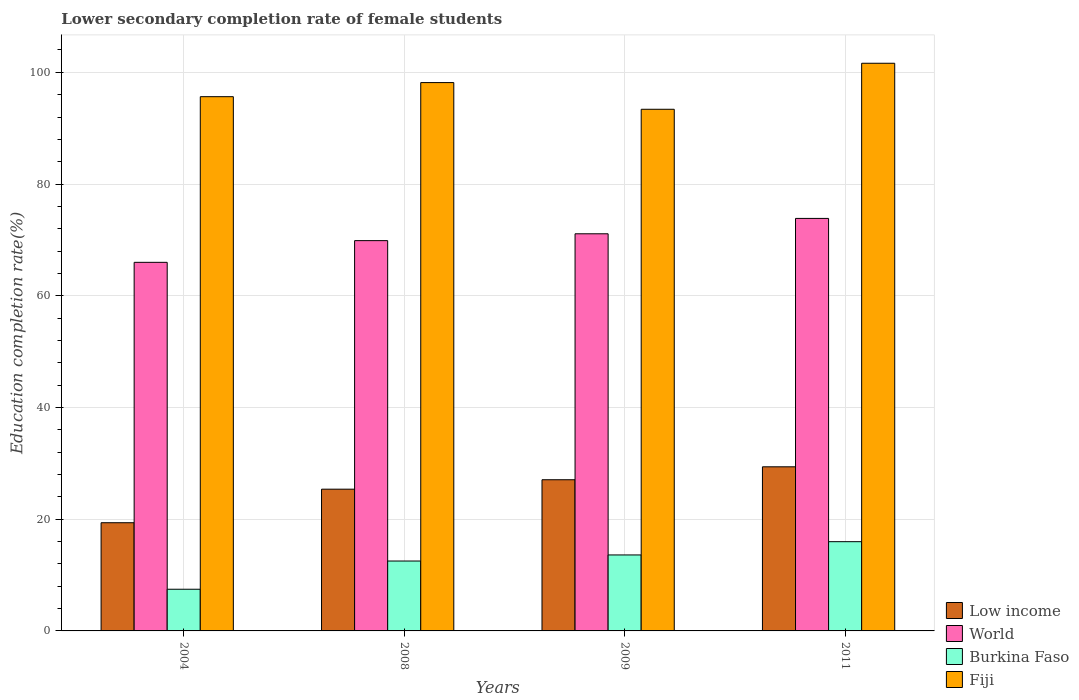How many different coloured bars are there?
Your answer should be very brief. 4. Are the number of bars on each tick of the X-axis equal?
Ensure brevity in your answer.  Yes. How many bars are there on the 3rd tick from the left?
Your response must be concise. 4. What is the lower secondary completion rate of female students in Fiji in 2004?
Give a very brief answer. 95.64. Across all years, what is the maximum lower secondary completion rate of female students in Fiji?
Provide a succinct answer. 101.62. Across all years, what is the minimum lower secondary completion rate of female students in Low income?
Provide a short and direct response. 19.37. In which year was the lower secondary completion rate of female students in World minimum?
Keep it short and to the point. 2004. What is the total lower secondary completion rate of female students in Burkina Faso in the graph?
Give a very brief answer. 49.55. What is the difference between the lower secondary completion rate of female students in Low income in 2008 and that in 2009?
Your response must be concise. -1.69. What is the difference between the lower secondary completion rate of female students in Fiji in 2011 and the lower secondary completion rate of female students in Burkina Faso in 2009?
Provide a short and direct response. 88.02. What is the average lower secondary completion rate of female students in World per year?
Keep it short and to the point. 70.2. In the year 2009, what is the difference between the lower secondary completion rate of female students in Low income and lower secondary completion rate of female students in World?
Offer a terse response. -44.03. In how many years, is the lower secondary completion rate of female students in Low income greater than 72 %?
Your answer should be compact. 0. What is the ratio of the lower secondary completion rate of female students in Fiji in 2008 to that in 2009?
Ensure brevity in your answer.  1.05. Is the difference between the lower secondary completion rate of female students in Low income in 2008 and 2011 greater than the difference between the lower secondary completion rate of female students in World in 2008 and 2011?
Offer a very short reply. No. What is the difference between the highest and the second highest lower secondary completion rate of female students in Fiji?
Offer a terse response. 3.46. What is the difference between the highest and the lowest lower secondary completion rate of female students in World?
Give a very brief answer. 7.86. In how many years, is the lower secondary completion rate of female students in Low income greater than the average lower secondary completion rate of female students in Low income taken over all years?
Give a very brief answer. 3. Is the sum of the lower secondary completion rate of female students in World in 2004 and 2011 greater than the maximum lower secondary completion rate of female students in Fiji across all years?
Ensure brevity in your answer.  Yes. What does the 1st bar from the left in 2009 represents?
Offer a very short reply. Low income. What does the 2nd bar from the right in 2004 represents?
Your answer should be compact. Burkina Faso. Are all the bars in the graph horizontal?
Offer a very short reply. No. How many years are there in the graph?
Ensure brevity in your answer.  4. What is the difference between two consecutive major ticks on the Y-axis?
Your answer should be compact. 20. Does the graph contain grids?
Make the answer very short. Yes. What is the title of the graph?
Provide a short and direct response. Lower secondary completion rate of female students. What is the label or title of the X-axis?
Your response must be concise. Years. What is the label or title of the Y-axis?
Ensure brevity in your answer.  Education completion rate(%). What is the Education completion rate(%) in Low income in 2004?
Ensure brevity in your answer.  19.37. What is the Education completion rate(%) in World in 2004?
Offer a very short reply. 65.98. What is the Education completion rate(%) in Burkina Faso in 2004?
Provide a short and direct response. 7.46. What is the Education completion rate(%) of Fiji in 2004?
Provide a short and direct response. 95.64. What is the Education completion rate(%) of Low income in 2008?
Your response must be concise. 25.38. What is the Education completion rate(%) in World in 2008?
Give a very brief answer. 69.87. What is the Education completion rate(%) of Burkina Faso in 2008?
Offer a very short reply. 12.51. What is the Education completion rate(%) in Fiji in 2008?
Your answer should be very brief. 98.16. What is the Education completion rate(%) in Low income in 2009?
Your answer should be compact. 27.06. What is the Education completion rate(%) in World in 2009?
Your answer should be compact. 71.09. What is the Education completion rate(%) of Burkina Faso in 2009?
Your response must be concise. 13.6. What is the Education completion rate(%) of Fiji in 2009?
Keep it short and to the point. 93.39. What is the Education completion rate(%) in Low income in 2011?
Your response must be concise. 29.38. What is the Education completion rate(%) in World in 2011?
Your answer should be very brief. 73.85. What is the Education completion rate(%) in Burkina Faso in 2011?
Provide a succinct answer. 15.98. What is the Education completion rate(%) of Fiji in 2011?
Ensure brevity in your answer.  101.62. Across all years, what is the maximum Education completion rate(%) of Low income?
Give a very brief answer. 29.38. Across all years, what is the maximum Education completion rate(%) of World?
Your response must be concise. 73.85. Across all years, what is the maximum Education completion rate(%) in Burkina Faso?
Provide a short and direct response. 15.98. Across all years, what is the maximum Education completion rate(%) of Fiji?
Offer a very short reply. 101.62. Across all years, what is the minimum Education completion rate(%) of Low income?
Your response must be concise. 19.37. Across all years, what is the minimum Education completion rate(%) of World?
Provide a short and direct response. 65.98. Across all years, what is the minimum Education completion rate(%) in Burkina Faso?
Provide a succinct answer. 7.46. Across all years, what is the minimum Education completion rate(%) in Fiji?
Offer a terse response. 93.39. What is the total Education completion rate(%) in Low income in the graph?
Your answer should be compact. 101.19. What is the total Education completion rate(%) of World in the graph?
Your response must be concise. 280.8. What is the total Education completion rate(%) in Burkina Faso in the graph?
Your response must be concise. 49.55. What is the total Education completion rate(%) in Fiji in the graph?
Offer a very short reply. 388.81. What is the difference between the Education completion rate(%) of Low income in 2004 and that in 2008?
Your answer should be very brief. -6.01. What is the difference between the Education completion rate(%) of World in 2004 and that in 2008?
Make the answer very short. -3.89. What is the difference between the Education completion rate(%) in Burkina Faso in 2004 and that in 2008?
Offer a terse response. -5.05. What is the difference between the Education completion rate(%) in Fiji in 2004 and that in 2008?
Provide a succinct answer. -2.52. What is the difference between the Education completion rate(%) in Low income in 2004 and that in 2009?
Offer a very short reply. -7.7. What is the difference between the Education completion rate(%) of World in 2004 and that in 2009?
Your response must be concise. -5.11. What is the difference between the Education completion rate(%) of Burkina Faso in 2004 and that in 2009?
Give a very brief answer. -6.14. What is the difference between the Education completion rate(%) of Fiji in 2004 and that in 2009?
Provide a short and direct response. 2.25. What is the difference between the Education completion rate(%) in Low income in 2004 and that in 2011?
Make the answer very short. -10.01. What is the difference between the Education completion rate(%) of World in 2004 and that in 2011?
Keep it short and to the point. -7.86. What is the difference between the Education completion rate(%) of Burkina Faso in 2004 and that in 2011?
Provide a succinct answer. -8.52. What is the difference between the Education completion rate(%) of Fiji in 2004 and that in 2011?
Offer a terse response. -5.98. What is the difference between the Education completion rate(%) in Low income in 2008 and that in 2009?
Your answer should be very brief. -1.69. What is the difference between the Education completion rate(%) of World in 2008 and that in 2009?
Provide a succinct answer. -1.22. What is the difference between the Education completion rate(%) of Burkina Faso in 2008 and that in 2009?
Give a very brief answer. -1.09. What is the difference between the Education completion rate(%) in Fiji in 2008 and that in 2009?
Ensure brevity in your answer.  4.78. What is the difference between the Education completion rate(%) of Low income in 2008 and that in 2011?
Your answer should be very brief. -4. What is the difference between the Education completion rate(%) in World in 2008 and that in 2011?
Give a very brief answer. -3.98. What is the difference between the Education completion rate(%) in Burkina Faso in 2008 and that in 2011?
Make the answer very short. -3.46. What is the difference between the Education completion rate(%) of Fiji in 2008 and that in 2011?
Provide a short and direct response. -3.46. What is the difference between the Education completion rate(%) of Low income in 2009 and that in 2011?
Your response must be concise. -2.31. What is the difference between the Education completion rate(%) of World in 2009 and that in 2011?
Ensure brevity in your answer.  -2.75. What is the difference between the Education completion rate(%) in Burkina Faso in 2009 and that in 2011?
Offer a terse response. -2.38. What is the difference between the Education completion rate(%) in Fiji in 2009 and that in 2011?
Give a very brief answer. -8.24. What is the difference between the Education completion rate(%) of Low income in 2004 and the Education completion rate(%) of World in 2008?
Your response must be concise. -50.5. What is the difference between the Education completion rate(%) of Low income in 2004 and the Education completion rate(%) of Burkina Faso in 2008?
Offer a terse response. 6.85. What is the difference between the Education completion rate(%) of Low income in 2004 and the Education completion rate(%) of Fiji in 2008?
Your response must be concise. -78.79. What is the difference between the Education completion rate(%) in World in 2004 and the Education completion rate(%) in Burkina Faso in 2008?
Keep it short and to the point. 53.47. What is the difference between the Education completion rate(%) in World in 2004 and the Education completion rate(%) in Fiji in 2008?
Provide a succinct answer. -32.18. What is the difference between the Education completion rate(%) in Burkina Faso in 2004 and the Education completion rate(%) in Fiji in 2008?
Keep it short and to the point. -90.7. What is the difference between the Education completion rate(%) in Low income in 2004 and the Education completion rate(%) in World in 2009?
Ensure brevity in your answer.  -51.73. What is the difference between the Education completion rate(%) of Low income in 2004 and the Education completion rate(%) of Burkina Faso in 2009?
Keep it short and to the point. 5.77. What is the difference between the Education completion rate(%) in Low income in 2004 and the Education completion rate(%) in Fiji in 2009?
Offer a terse response. -74.02. What is the difference between the Education completion rate(%) in World in 2004 and the Education completion rate(%) in Burkina Faso in 2009?
Your response must be concise. 52.38. What is the difference between the Education completion rate(%) in World in 2004 and the Education completion rate(%) in Fiji in 2009?
Give a very brief answer. -27.4. What is the difference between the Education completion rate(%) of Burkina Faso in 2004 and the Education completion rate(%) of Fiji in 2009?
Your answer should be compact. -85.93. What is the difference between the Education completion rate(%) of Low income in 2004 and the Education completion rate(%) of World in 2011?
Your response must be concise. -54.48. What is the difference between the Education completion rate(%) in Low income in 2004 and the Education completion rate(%) in Burkina Faso in 2011?
Give a very brief answer. 3.39. What is the difference between the Education completion rate(%) in Low income in 2004 and the Education completion rate(%) in Fiji in 2011?
Keep it short and to the point. -82.26. What is the difference between the Education completion rate(%) of World in 2004 and the Education completion rate(%) of Burkina Faso in 2011?
Your answer should be very brief. 50.01. What is the difference between the Education completion rate(%) in World in 2004 and the Education completion rate(%) in Fiji in 2011?
Offer a very short reply. -35.64. What is the difference between the Education completion rate(%) of Burkina Faso in 2004 and the Education completion rate(%) of Fiji in 2011?
Provide a succinct answer. -94.16. What is the difference between the Education completion rate(%) in Low income in 2008 and the Education completion rate(%) in World in 2009?
Make the answer very short. -45.72. What is the difference between the Education completion rate(%) in Low income in 2008 and the Education completion rate(%) in Burkina Faso in 2009?
Ensure brevity in your answer.  11.78. What is the difference between the Education completion rate(%) of Low income in 2008 and the Education completion rate(%) of Fiji in 2009?
Your answer should be very brief. -68.01. What is the difference between the Education completion rate(%) in World in 2008 and the Education completion rate(%) in Burkina Faso in 2009?
Your response must be concise. 56.27. What is the difference between the Education completion rate(%) in World in 2008 and the Education completion rate(%) in Fiji in 2009?
Offer a very short reply. -23.52. What is the difference between the Education completion rate(%) in Burkina Faso in 2008 and the Education completion rate(%) in Fiji in 2009?
Make the answer very short. -80.87. What is the difference between the Education completion rate(%) of Low income in 2008 and the Education completion rate(%) of World in 2011?
Provide a short and direct response. -48.47. What is the difference between the Education completion rate(%) of Low income in 2008 and the Education completion rate(%) of Burkina Faso in 2011?
Provide a short and direct response. 9.4. What is the difference between the Education completion rate(%) of Low income in 2008 and the Education completion rate(%) of Fiji in 2011?
Give a very brief answer. -76.25. What is the difference between the Education completion rate(%) in World in 2008 and the Education completion rate(%) in Burkina Faso in 2011?
Ensure brevity in your answer.  53.89. What is the difference between the Education completion rate(%) in World in 2008 and the Education completion rate(%) in Fiji in 2011?
Your answer should be very brief. -31.75. What is the difference between the Education completion rate(%) of Burkina Faso in 2008 and the Education completion rate(%) of Fiji in 2011?
Ensure brevity in your answer.  -89.11. What is the difference between the Education completion rate(%) in Low income in 2009 and the Education completion rate(%) in World in 2011?
Provide a succinct answer. -46.78. What is the difference between the Education completion rate(%) in Low income in 2009 and the Education completion rate(%) in Burkina Faso in 2011?
Provide a succinct answer. 11.09. What is the difference between the Education completion rate(%) in Low income in 2009 and the Education completion rate(%) in Fiji in 2011?
Your response must be concise. -74.56. What is the difference between the Education completion rate(%) of World in 2009 and the Education completion rate(%) of Burkina Faso in 2011?
Keep it short and to the point. 55.12. What is the difference between the Education completion rate(%) in World in 2009 and the Education completion rate(%) in Fiji in 2011?
Your response must be concise. -30.53. What is the difference between the Education completion rate(%) in Burkina Faso in 2009 and the Education completion rate(%) in Fiji in 2011?
Provide a succinct answer. -88.02. What is the average Education completion rate(%) in Low income per year?
Provide a short and direct response. 25.3. What is the average Education completion rate(%) of World per year?
Give a very brief answer. 70.2. What is the average Education completion rate(%) in Burkina Faso per year?
Provide a short and direct response. 12.39. What is the average Education completion rate(%) in Fiji per year?
Give a very brief answer. 97.2. In the year 2004, what is the difference between the Education completion rate(%) in Low income and Education completion rate(%) in World?
Provide a short and direct response. -46.62. In the year 2004, what is the difference between the Education completion rate(%) of Low income and Education completion rate(%) of Burkina Faso?
Your response must be concise. 11.91. In the year 2004, what is the difference between the Education completion rate(%) in Low income and Education completion rate(%) in Fiji?
Give a very brief answer. -76.27. In the year 2004, what is the difference between the Education completion rate(%) in World and Education completion rate(%) in Burkina Faso?
Make the answer very short. 58.52. In the year 2004, what is the difference between the Education completion rate(%) of World and Education completion rate(%) of Fiji?
Provide a short and direct response. -29.66. In the year 2004, what is the difference between the Education completion rate(%) of Burkina Faso and Education completion rate(%) of Fiji?
Give a very brief answer. -88.18. In the year 2008, what is the difference between the Education completion rate(%) in Low income and Education completion rate(%) in World?
Your answer should be compact. -44.5. In the year 2008, what is the difference between the Education completion rate(%) in Low income and Education completion rate(%) in Burkina Faso?
Your answer should be compact. 12.86. In the year 2008, what is the difference between the Education completion rate(%) in Low income and Education completion rate(%) in Fiji?
Your answer should be compact. -72.79. In the year 2008, what is the difference between the Education completion rate(%) in World and Education completion rate(%) in Burkina Faso?
Your response must be concise. 57.36. In the year 2008, what is the difference between the Education completion rate(%) of World and Education completion rate(%) of Fiji?
Provide a short and direct response. -28.29. In the year 2008, what is the difference between the Education completion rate(%) in Burkina Faso and Education completion rate(%) in Fiji?
Offer a very short reply. -85.65. In the year 2009, what is the difference between the Education completion rate(%) in Low income and Education completion rate(%) in World?
Your response must be concise. -44.03. In the year 2009, what is the difference between the Education completion rate(%) of Low income and Education completion rate(%) of Burkina Faso?
Make the answer very short. 13.46. In the year 2009, what is the difference between the Education completion rate(%) in Low income and Education completion rate(%) in Fiji?
Keep it short and to the point. -66.32. In the year 2009, what is the difference between the Education completion rate(%) in World and Education completion rate(%) in Burkina Faso?
Ensure brevity in your answer.  57.49. In the year 2009, what is the difference between the Education completion rate(%) in World and Education completion rate(%) in Fiji?
Offer a terse response. -22.29. In the year 2009, what is the difference between the Education completion rate(%) of Burkina Faso and Education completion rate(%) of Fiji?
Offer a very short reply. -79.79. In the year 2011, what is the difference between the Education completion rate(%) of Low income and Education completion rate(%) of World?
Your answer should be very brief. -44.47. In the year 2011, what is the difference between the Education completion rate(%) of Low income and Education completion rate(%) of Burkina Faso?
Your answer should be very brief. 13.4. In the year 2011, what is the difference between the Education completion rate(%) in Low income and Education completion rate(%) in Fiji?
Offer a very short reply. -72.24. In the year 2011, what is the difference between the Education completion rate(%) of World and Education completion rate(%) of Burkina Faso?
Provide a succinct answer. 57.87. In the year 2011, what is the difference between the Education completion rate(%) of World and Education completion rate(%) of Fiji?
Your answer should be compact. -27.78. In the year 2011, what is the difference between the Education completion rate(%) of Burkina Faso and Education completion rate(%) of Fiji?
Give a very brief answer. -85.65. What is the ratio of the Education completion rate(%) of Low income in 2004 to that in 2008?
Give a very brief answer. 0.76. What is the ratio of the Education completion rate(%) of Burkina Faso in 2004 to that in 2008?
Offer a terse response. 0.6. What is the ratio of the Education completion rate(%) in Fiji in 2004 to that in 2008?
Your answer should be very brief. 0.97. What is the ratio of the Education completion rate(%) in Low income in 2004 to that in 2009?
Provide a short and direct response. 0.72. What is the ratio of the Education completion rate(%) of World in 2004 to that in 2009?
Make the answer very short. 0.93. What is the ratio of the Education completion rate(%) in Burkina Faso in 2004 to that in 2009?
Make the answer very short. 0.55. What is the ratio of the Education completion rate(%) of Fiji in 2004 to that in 2009?
Offer a very short reply. 1.02. What is the ratio of the Education completion rate(%) in Low income in 2004 to that in 2011?
Provide a succinct answer. 0.66. What is the ratio of the Education completion rate(%) in World in 2004 to that in 2011?
Offer a terse response. 0.89. What is the ratio of the Education completion rate(%) in Burkina Faso in 2004 to that in 2011?
Your answer should be very brief. 0.47. What is the ratio of the Education completion rate(%) in Fiji in 2004 to that in 2011?
Your answer should be very brief. 0.94. What is the ratio of the Education completion rate(%) of Low income in 2008 to that in 2009?
Make the answer very short. 0.94. What is the ratio of the Education completion rate(%) of World in 2008 to that in 2009?
Provide a succinct answer. 0.98. What is the ratio of the Education completion rate(%) in Burkina Faso in 2008 to that in 2009?
Provide a short and direct response. 0.92. What is the ratio of the Education completion rate(%) in Fiji in 2008 to that in 2009?
Give a very brief answer. 1.05. What is the ratio of the Education completion rate(%) in Low income in 2008 to that in 2011?
Ensure brevity in your answer.  0.86. What is the ratio of the Education completion rate(%) of World in 2008 to that in 2011?
Provide a succinct answer. 0.95. What is the ratio of the Education completion rate(%) in Burkina Faso in 2008 to that in 2011?
Give a very brief answer. 0.78. What is the ratio of the Education completion rate(%) of Fiji in 2008 to that in 2011?
Your response must be concise. 0.97. What is the ratio of the Education completion rate(%) of Low income in 2009 to that in 2011?
Provide a succinct answer. 0.92. What is the ratio of the Education completion rate(%) of World in 2009 to that in 2011?
Ensure brevity in your answer.  0.96. What is the ratio of the Education completion rate(%) of Burkina Faso in 2009 to that in 2011?
Provide a short and direct response. 0.85. What is the ratio of the Education completion rate(%) of Fiji in 2009 to that in 2011?
Ensure brevity in your answer.  0.92. What is the difference between the highest and the second highest Education completion rate(%) in Low income?
Your answer should be very brief. 2.31. What is the difference between the highest and the second highest Education completion rate(%) of World?
Make the answer very short. 2.75. What is the difference between the highest and the second highest Education completion rate(%) in Burkina Faso?
Keep it short and to the point. 2.38. What is the difference between the highest and the second highest Education completion rate(%) of Fiji?
Make the answer very short. 3.46. What is the difference between the highest and the lowest Education completion rate(%) of Low income?
Offer a terse response. 10.01. What is the difference between the highest and the lowest Education completion rate(%) in World?
Keep it short and to the point. 7.86. What is the difference between the highest and the lowest Education completion rate(%) of Burkina Faso?
Make the answer very short. 8.52. What is the difference between the highest and the lowest Education completion rate(%) of Fiji?
Your answer should be compact. 8.24. 